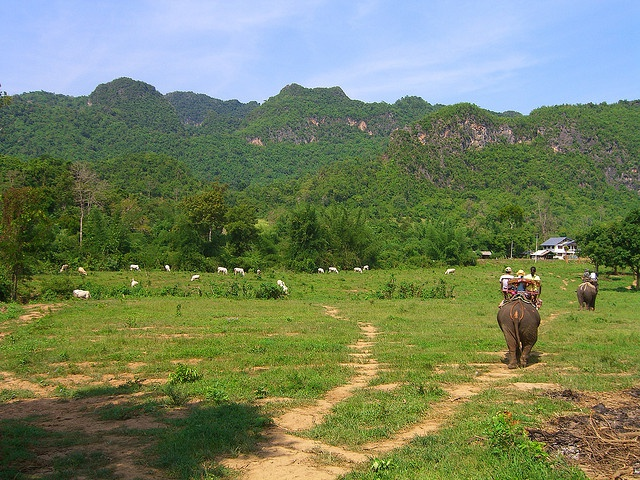Describe the objects in this image and their specific colors. I can see elephant in lightblue, maroon, black, and gray tones, cow in lightblue, darkgreen, olive, and black tones, elephant in lightblue, black, and gray tones, people in lightblue, beige, black, and olive tones, and people in lightblue, white, black, olive, and beige tones in this image. 